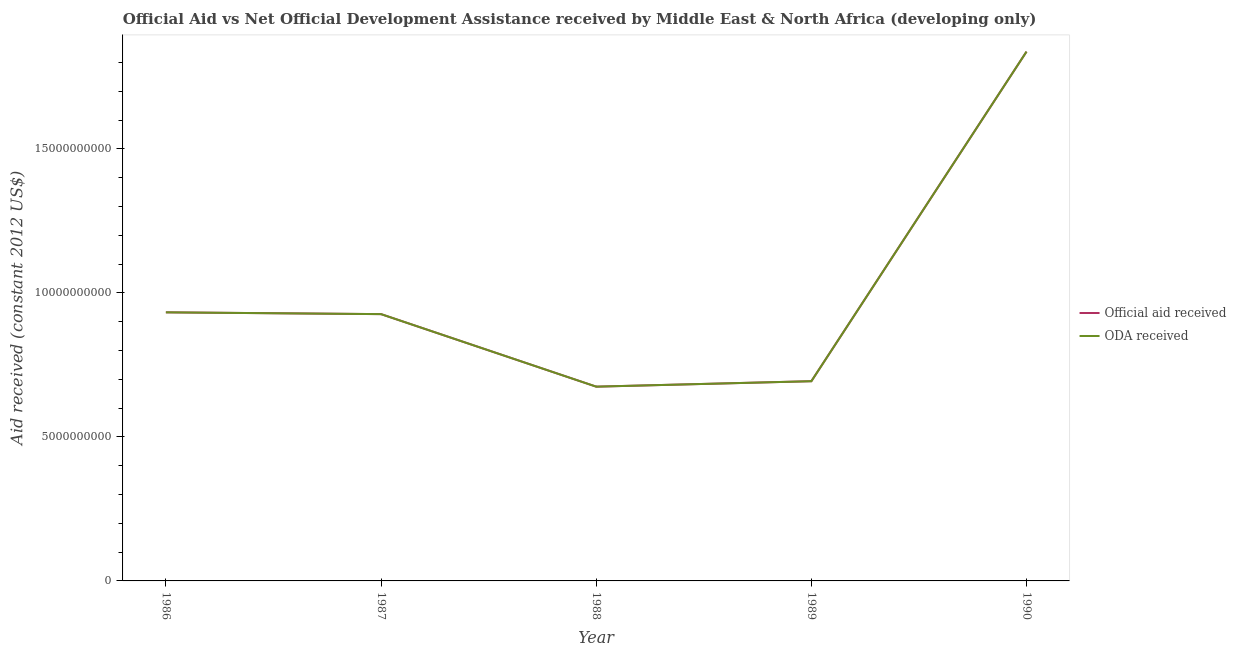Is the number of lines equal to the number of legend labels?
Your answer should be very brief. Yes. What is the oda received in 1987?
Provide a short and direct response. 9.26e+09. Across all years, what is the maximum oda received?
Ensure brevity in your answer.  1.84e+1. Across all years, what is the minimum oda received?
Offer a very short reply. 6.74e+09. In which year was the oda received maximum?
Your answer should be compact. 1990. In which year was the oda received minimum?
Your answer should be very brief. 1988. What is the total oda received in the graph?
Give a very brief answer. 5.06e+1. What is the difference between the oda received in 1986 and that in 1987?
Offer a very short reply. 6.17e+07. What is the difference between the oda received in 1989 and the official aid received in 1988?
Ensure brevity in your answer.  1.89e+08. What is the average oda received per year?
Make the answer very short. 1.01e+1. What is the ratio of the official aid received in 1986 to that in 1989?
Make the answer very short. 1.34. Is the official aid received in 1986 less than that in 1988?
Your response must be concise. No. What is the difference between the highest and the second highest oda received?
Your response must be concise. 9.05e+09. What is the difference between the highest and the lowest official aid received?
Ensure brevity in your answer.  1.16e+1. In how many years, is the official aid received greater than the average official aid received taken over all years?
Offer a very short reply. 1. What is the difference between two consecutive major ticks on the Y-axis?
Make the answer very short. 5.00e+09. Are the values on the major ticks of Y-axis written in scientific E-notation?
Offer a terse response. No. Does the graph contain grids?
Your answer should be very brief. No. Where does the legend appear in the graph?
Keep it short and to the point. Center right. How many legend labels are there?
Provide a succinct answer. 2. How are the legend labels stacked?
Offer a terse response. Vertical. What is the title of the graph?
Make the answer very short. Official Aid vs Net Official Development Assistance received by Middle East & North Africa (developing only) . Does "Time to export" appear as one of the legend labels in the graph?
Provide a succinct answer. No. What is the label or title of the X-axis?
Provide a succinct answer. Year. What is the label or title of the Y-axis?
Your answer should be very brief. Aid received (constant 2012 US$). What is the Aid received (constant 2012 US$) of Official aid received in 1986?
Provide a short and direct response. 9.32e+09. What is the Aid received (constant 2012 US$) of ODA received in 1986?
Your answer should be very brief. 9.32e+09. What is the Aid received (constant 2012 US$) in Official aid received in 1987?
Keep it short and to the point. 9.26e+09. What is the Aid received (constant 2012 US$) in ODA received in 1987?
Keep it short and to the point. 9.26e+09. What is the Aid received (constant 2012 US$) of Official aid received in 1988?
Your response must be concise. 6.74e+09. What is the Aid received (constant 2012 US$) in ODA received in 1988?
Your answer should be compact. 6.74e+09. What is the Aid received (constant 2012 US$) of Official aid received in 1989?
Give a very brief answer. 6.93e+09. What is the Aid received (constant 2012 US$) of ODA received in 1989?
Provide a short and direct response. 6.93e+09. What is the Aid received (constant 2012 US$) in Official aid received in 1990?
Give a very brief answer. 1.84e+1. What is the Aid received (constant 2012 US$) in ODA received in 1990?
Your answer should be very brief. 1.84e+1. Across all years, what is the maximum Aid received (constant 2012 US$) in Official aid received?
Ensure brevity in your answer.  1.84e+1. Across all years, what is the maximum Aid received (constant 2012 US$) in ODA received?
Offer a terse response. 1.84e+1. Across all years, what is the minimum Aid received (constant 2012 US$) of Official aid received?
Provide a short and direct response. 6.74e+09. Across all years, what is the minimum Aid received (constant 2012 US$) in ODA received?
Ensure brevity in your answer.  6.74e+09. What is the total Aid received (constant 2012 US$) in Official aid received in the graph?
Provide a succinct answer. 5.06e+1. What is the total Aid received (constant 2012 US$) in ODA received in the graph?
Give a very brief answer. 5.06e+1. What is the difference between the Aid received (constant 2012 US$) in Official aid received in 1986 and that in 1987?
Give a very brief answer. 6.17e+07. What is the difference between the Aid received (constant 2012 US$) of ODA received in 1986 and that in 1987?
Make the answer very short. 6.17e+07. What is the difference between the Aid received (constant 2012 US$) in Official aid received in 1986 and that in 1988?
Offer a very short reply. 2.58e+09. What is the difference between the Aid received (constant 2012 US$) of ODA received in 1986 and that in 1988?
Ensure brevity in your answer.  2.58e+09. What is the difference between the Aid received (constant 2012 US$) in Official aid received in 1986 and that in 1989?
Give a very brief answer. 2.39e+09. What is the difference between the Aid received (constant 2012 US$) of ODA received in 1986 and that in 1989?
Your answer should be compact. 2.39e+09. What is the difference between the Aid received (constant 2012 US$) in Official aid received in 1986 and that in 1990?
Make the answer very short. -9.05e+09. What is the difference between the Aid received (constant 2012 US$) in ODA received in 1986 and that in 1990?
Keep it short and to the point. -9.05e+09. What is the difference between the Aid received (constant 2012 US$) in Official aid received in 1987 and that in 1988?
Provide a short and direct response. 2.52e+09. What is the difference between the Aid received (constant 2012 US$) in ODA received in 1987 and that in 1988?
Provide a short and direct response. 2.52e+09. What is the difference between the Aid received (constant 2012 US$) of Official aid received in 1987 and that in 1989?
Provide a short and direct response. 2.33e+09. What is the difference between the Aid received (constant 2012 US$) of ODA received in 1987 and that in 1989?
Provide a succinct answer. 2.33e+09. What is the difference between the Aid received (constant 2012 US$) in Official aid received in 1987 and that in 1990?
Offer a very short reply. -9.11e+09. What is the difference between the Aid received (constant 2012 US$) of ODA received in 1987 and that in 1990?
Your answer should be very brief. -9.11e+09. What is the difference between the Aid received (constant 2012 US$) in Official aid received in 1988 and that in 1989?
Make the answer very short. -1.89e+08. What is the difference between the Aid received (constant 2012 US$) in ODA received in 1988 and that in 1989?
Make the answer very short. -1.89e+08. What is the difference between the Aid received (constant 2012 US$) in Official aid received in 1988 and that in 1990?
Give a very brief answer. -1.16e+1. What is the difference between the Aid received (constant 2012 US$) in ODA received in 1988 and that in 1990?
Offer a terse response. -1.16e+1. What is the difference between the Aid received (constant 2012 US$) in Official aid received in 1989 and that in 1990?
Your response must be concise. -1.14e+1. What is the difference between the Aid received (constant 2012 US$) in ODA received in 1989 and that in 1990?
Offer a terse response. -1.14e+1. What is the difference between the Aid received (constant 2012 US$) in Official aid received in 1986 and the Aid received (constant 2012 US$) in ODA received in 1987?
Your answer should be very brief. 6.17e+07. What is the difference between the Aid received (constant 2012 US$) of Official aid received in 1986 and the Aid received (constant 2012 US$) of ODA received in 1988?
Ensure brevity in your answer.  2.58e+09. What is the difference between the Aid received (constant 2012 US$) in Official aid received in 1986 and the Aid received (constant 2012 US$) in ODA received in 1989?
Offer a terse response. 2.39e+09. What is the difference between the Aid received (constant 2012 US$) in Official aid received in 1986 and the Aid received (constant 2012 US$) in ODA received in 1990?
Offer a very short reply. -9.05e+09. What is the difference between the Aid received (constant 2012 US$) in Official aid received in 1987 and the Aid received (constant 2012 US$) in ODA received in 1988?
Offer a terse response. 2.52e+09. What is the difference between the Aid received (constant 2012 US$) in Official aid received in 1987 and the Aid received (constant 2012 US$) in ODA received in 1989?
Offer a very short reply. 2.33e+09. What is the difference between the Aid received (constant 2012 US$) in Official aid received in 1987 and the Aid received (constant 2012 US$) in ODA received in 1990?
Your response must be concise. -9.11e+09. What is the difference between the Aid received (constant 2012 US$) in Official aid received in 1988 and the Aid received (constant 2012 US$) in ODA received in 1989?
Give a very brief answer. -1.89e+08. What is the difference between the Aid received (constant 2012 US$) in Official aid received in 1988 and the Aid received (constant 2012 US$) in ODA received in 1990?
Ensure brevity in your answer.  -1.16e+1. What is the difference between the Aid received (constant 2012 US$) in Official aid received in 1989 and the Aid received (constant 2012 US$) in ODA received in 1990?
Make the answer very short. -1.14e+1. What is the average Aid received (constant 2012 US$) in Official aid received per year?
Your answer should be very brief. 1.01e+1. What is the average Aid received (constant 2012 US$) of ODA received per year?
Offer a very short reply. 1.01e+1. In the year 1988, what is the difference between the Aid received (constant 2012 US$) in Official aid received and Aid received (constant 2012 US$) in ODA received?
Keep it short and to the point. 0. In the year 1989, what is the difference between the Aid received (constant 2012 US$) of Official aid received and Aid received (constant 2012 US$) of ODA received?
Ensure brevity in your answer.  0. In the year 1990, what is the difference between the Aid received (constant 2012 US$) in Official aid received and Aid received (constant 2012 US$) in ODA received?
Offer a very short reply. 0. What is the ratio of the Aid received (constant 2012 US$) of Official aid received in 1986 to that in 1987?
Your response must be concise. 1.01. What is the ratio of the Aid received (constant 2012 US$) of Official aid received in 1986 to that in 1988?
Provide a succinct answer. 1.38. What is the ratio of the Aid received (constant 2012 US$) of ODA received in 1986 to that in 1988?
Make the answer very short. 1.38. What is the ratio of the Aid received (constant 2012 US$) of Official aid received in 1986 to that in 1989?
Provide a short and direct response. 1.34. What is the ratio of the Aid received (constant 2012 US$) in ODA received in 1986 to that in 1989?
Offer a very short reply. 1.34. What is the ratio of the Aid received (constant 2012 US$) in Official aid received in 1986 to that in 1990?
Offer a very short reply. 0.51. What is the ratio of the Aid received (constant 2012 US$) in ODA received in 1986 to that in 1990?
Your answer should be very brief. 0.51. What is the ratio of the Aid received (constant 2012 US$) in Official aid received in 1987 to that in 1988?
Your answer should be compact. 1.37. What is the ratio of the Aid received (constant 2012 US$) in ODA received in 1987 to that in 1988?
Provide a succinct answer. 1.37. What is the ratio of the Aid received (constant 2012 US$) in Official aid received in 1987 to that in 1989?
Provide a succinct answer. 1.34. What is the ratio of the Aid received (constant 2012 US$) in ODA received in 1987 to that in 1989?
Your response must be concise. 1.34. What is the ratio of the Aid received (constant 2012 US$) of Official aid received in 1987 to that in 1990?
Your response must be concise. 0.5. What is the ratio of the Aid received (constant 2012 US$) in ODA received in 1987 to that in 1990?
Give a very brief answer. 0.5. What is the ratio of the Aid received (constant 2012 US$) of Official aid received in 1988 to that in 1989?
Your answer should be very brief. 0.97. What is the ratio of the Aid received (constant 2012 US$) in ODA received in 1988 to that in 1989?
Offer a very short reply. 0.97. What is the ratio of the Aid received (constant 2012 US$) of Official aid received in 1988 to that in 1990?
Your answer should be very brief. 0.37. What is the ratio of the Aid received (constant 2012 US$) of ODA received in 1988 to that in 1990?
Offer a very short reply. 0.37. What is the ratio of the Aid received (constant 2012 US$) in Official aid received in 1989 to that in 1990?
Offer a very short reply. 0.38. What is the ratio of the Aid received (constant 2012 US$) in ODA received in 1989 to that in 1990?
Make the answer very short. 0.38. What is the difference between the highest and the second highest Aid received (constant 2012 US$) in Official aid received?
Provide a short and direct response. 9.05e+09. What is the difference between the highest and the second highest Aid received (constant 2012 US$) in ODA received?
Ensure brevity in your answer.  9.05e+09. What is the difference between the highest and the lowest Aid received (constant 2012 US$) in Official aid received?
Provide a succinct answer. 1.16e+1. What is the difference between the highest and the lowest Aid received (constant 2012 US$) of ODA received?
Give a very brief answer. 1.16e+1. 